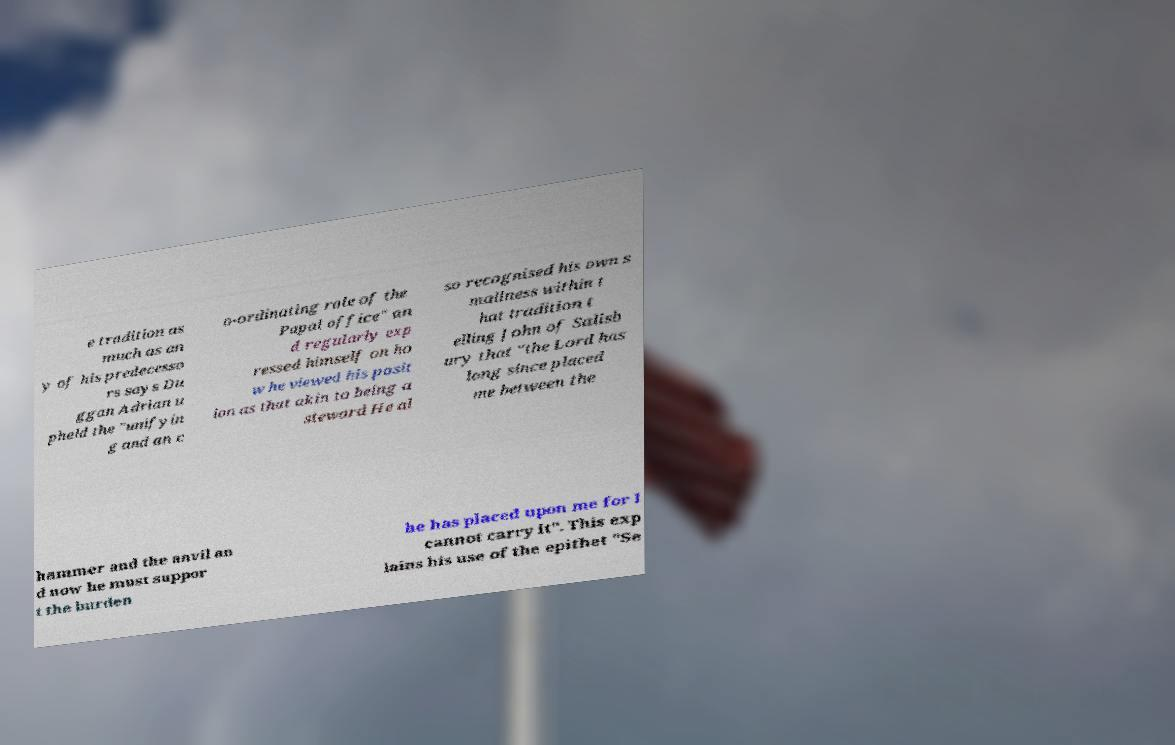Please identify and transcribe the text found in this image. e tradition as much as an y of his predecesso rs says Du ggan Adrian u pheld the "unifyin g and an c o-ordinating role of the Papal office" an d regularly exp ressed himself on ho w he viewed his posit ion as that akin to being a steward He al so recognised his own s mallness within t hat tradition t elling John of Salisb ury that "the Lord has long since placed me between the hammer and the anvil an d now he must suppor t the burden he has placed upon me for I cannot carry it". This exp lains his use of the epithet "Se 